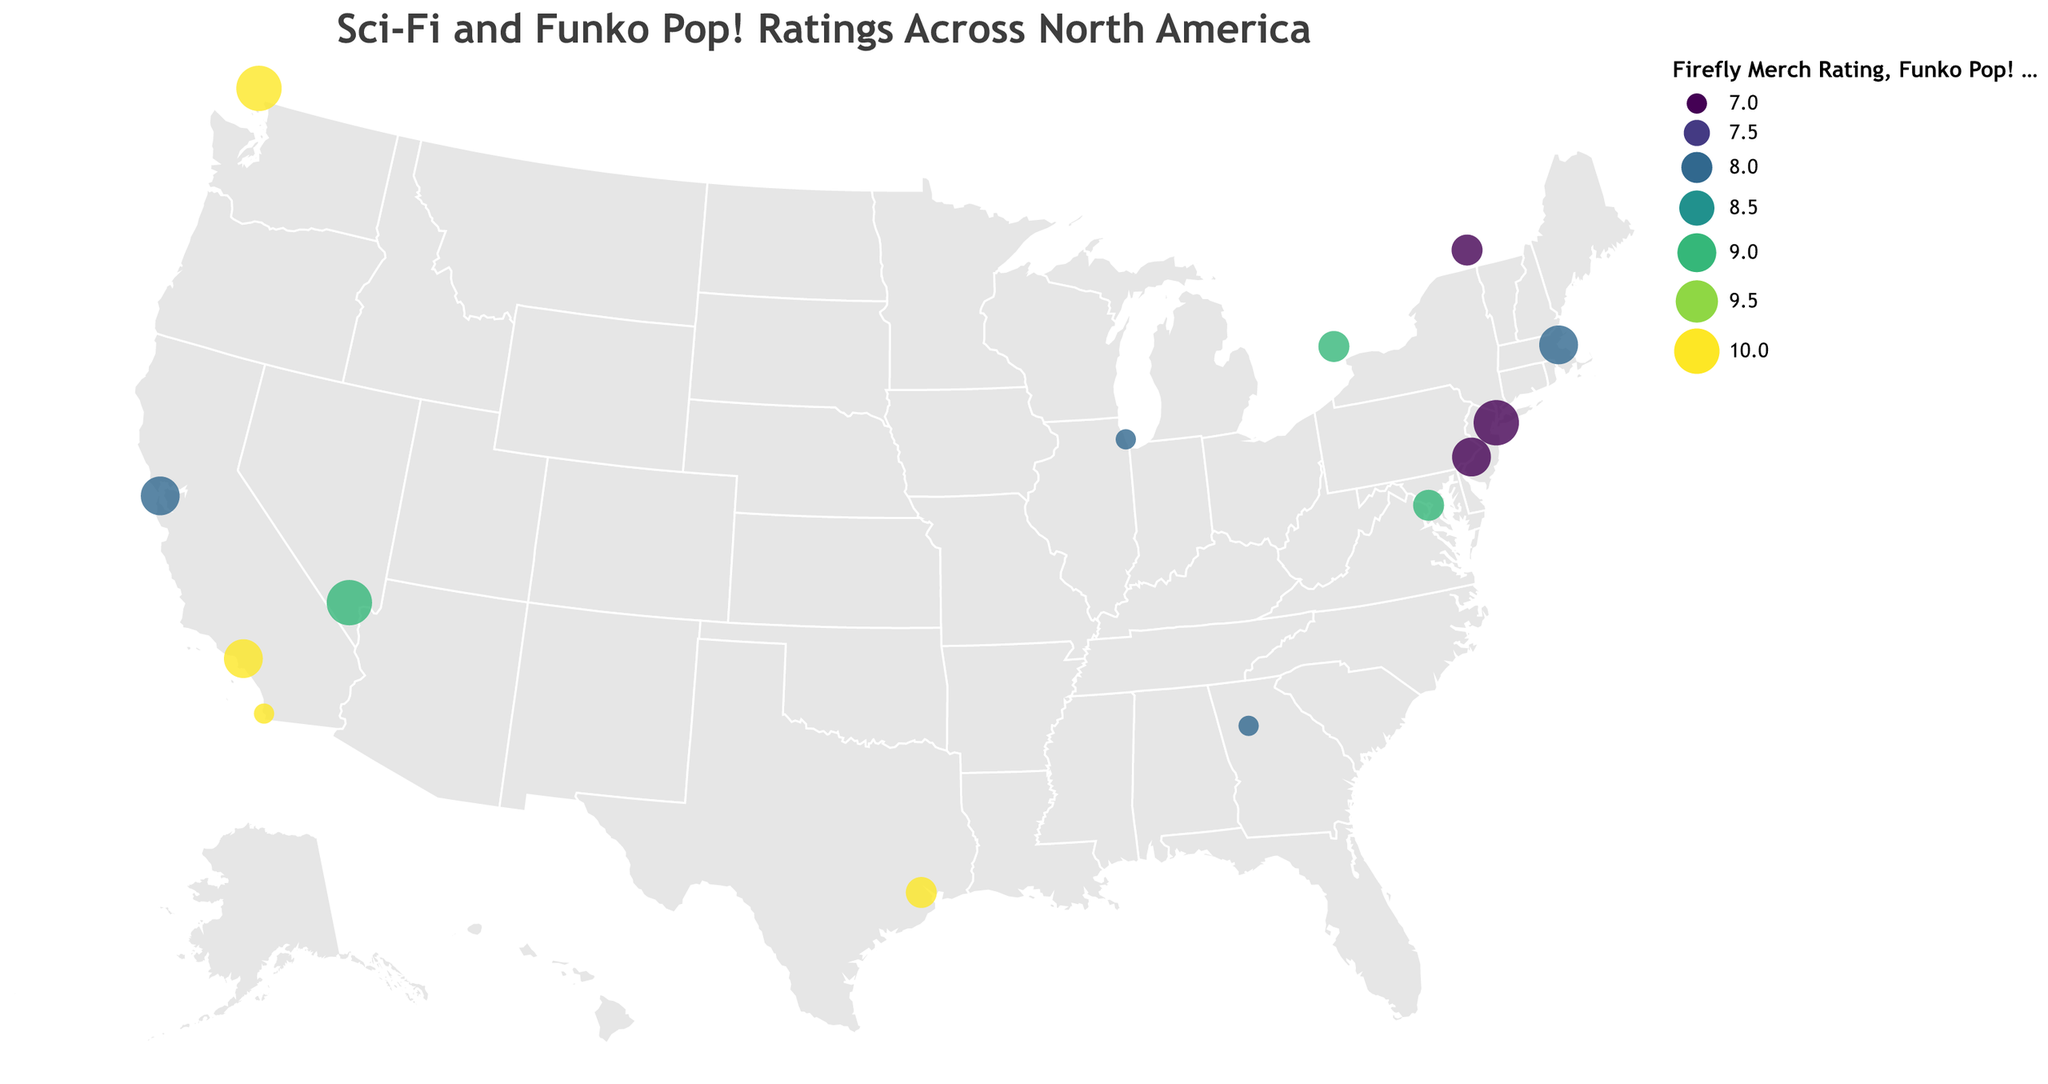How many stores have a perfect Firefly Merch Rating of 10? Look at the color scale for Firefly Merch Rating and identify the data points that correspond to the highest rating of 10.
Answer: 5 Which store has the highest Funko Pop! Rating and also sells Firefly merchandise rated 10? Identify the store where both the Funko Pop! Rating and Firefly Merch Rating are at their highest values by scanning the corresponding encodings in the tooltip.
Answer: Serenity Figures What are the average Funko Pop! and Firefly Merch Ratings for stores in California (latitude and longitude indicate location)? Identify stores located in California (around lat 37-34, long -122). Sum their ratings and divide by the number of stores. Atomic Comics and Geek Out! have respective ratings leading to averages.
Answer: Funko Pop! Rating: 9, Firefly Merch Rating: 9 Which store is located furthest north and what are its ratings? Find the store with the highest latitude (y-axis value). Check its tooltip for the ratings.
Answer: Serenity Figures: Funko Pop! Rating: 10, Firefly Merch Rating: 10 How many stores have a Funko Pop! Rating of 9? Identify data points with size encoding corresponding to a rating of 9 by referring to the size legend.
Answer: 4 Which store has the lowest combined rating of both Funko Pop! and Firefly Merch and what is its combined rating? Calculate the sum of both ratings for each store and identify the store with the smallest total.
Answer: Alliance Outpost: 15 (7 + 8) Which store located in New York has the highest Funko Pop! Rating, and what is its Firefly Merch Rating? Identify the store located at the coordinates for New York (40.7128, -74.0060) and check its ratings from the tooltip.
Answer: Fanboy Collectibles: Firefly Merch Rating: 7 How many stores have a higher Firefly Merch Rating than their Funko Pop! Rating? Compare the Firefly Merch Rating and Funko Pop! Rating for each store to count instances where Firefly Merch Rating is greater.
Answer: 3 Is there any store rating scheme that suggests it specializes more in Firefly merchandise than Funko Pop! figures? Look for stores with higher Firefly Merch Ratings compared to Funko Pop! Ratings by comparing colors and sizes of the data points.
Answer: Yes Which store is located closest to latitude 34 and longitude -118 and what are its ratings? Find the data point closest to these coordinates and reference the tooltip for its ratings.
Answer: Geek Out!: Funko Pop! Rating: 9, Firefly Merch Rating: 10 